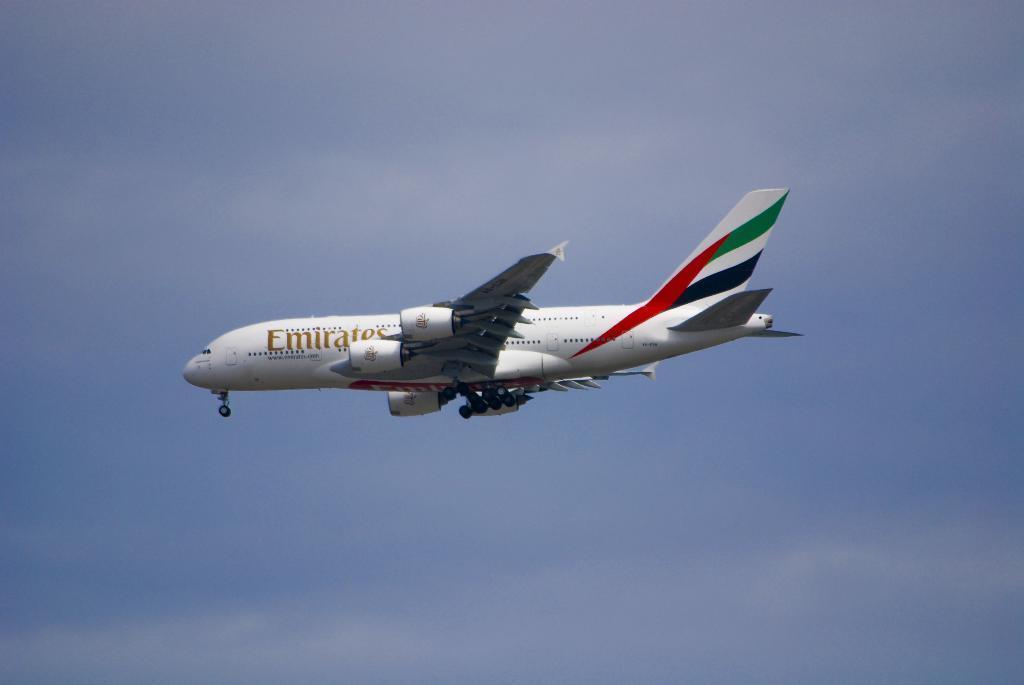Please provide a concise description of this image. In the center of the image we can see the Emirates airplane and in the background we can see the sky. 